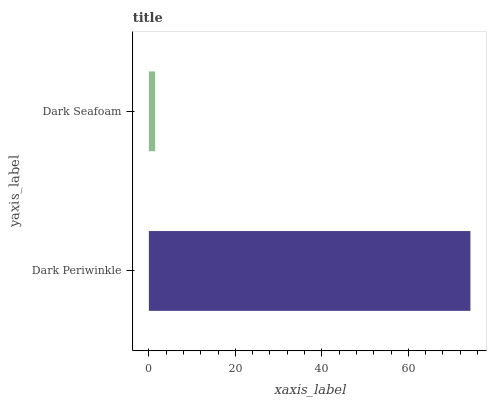Is Dark Seafoam the minimum?
Answer yes or no. Yes. Is Dark Periwinkle the maximum?
Answer yes or no. Yes. Is Dark Seafoam the maximum?
Answer yes or no. No. Is Dark Periwinkle greater than Dark Seafoam?
Answer yes or no. Yes. Is Dark Seafoam less than Dark Periwinkle?
Answer yes or no. Yes. Is Dark Seafoam greater than Dark Periwinkle?
Answer yes or no. No. Is Dark Periwinkle less than Dark Seafoam?
Answer yes or no. No. Is Dark Periwinkle the high median?
Answer yes or no. Yes. Is Dark Seafoam the low median?
Answer yes or no. Yes. Is Dark Seafoam the high median?
Answer yes or no. No. Is Dark Periwinkle the low median?
Answer yes or no. No. 